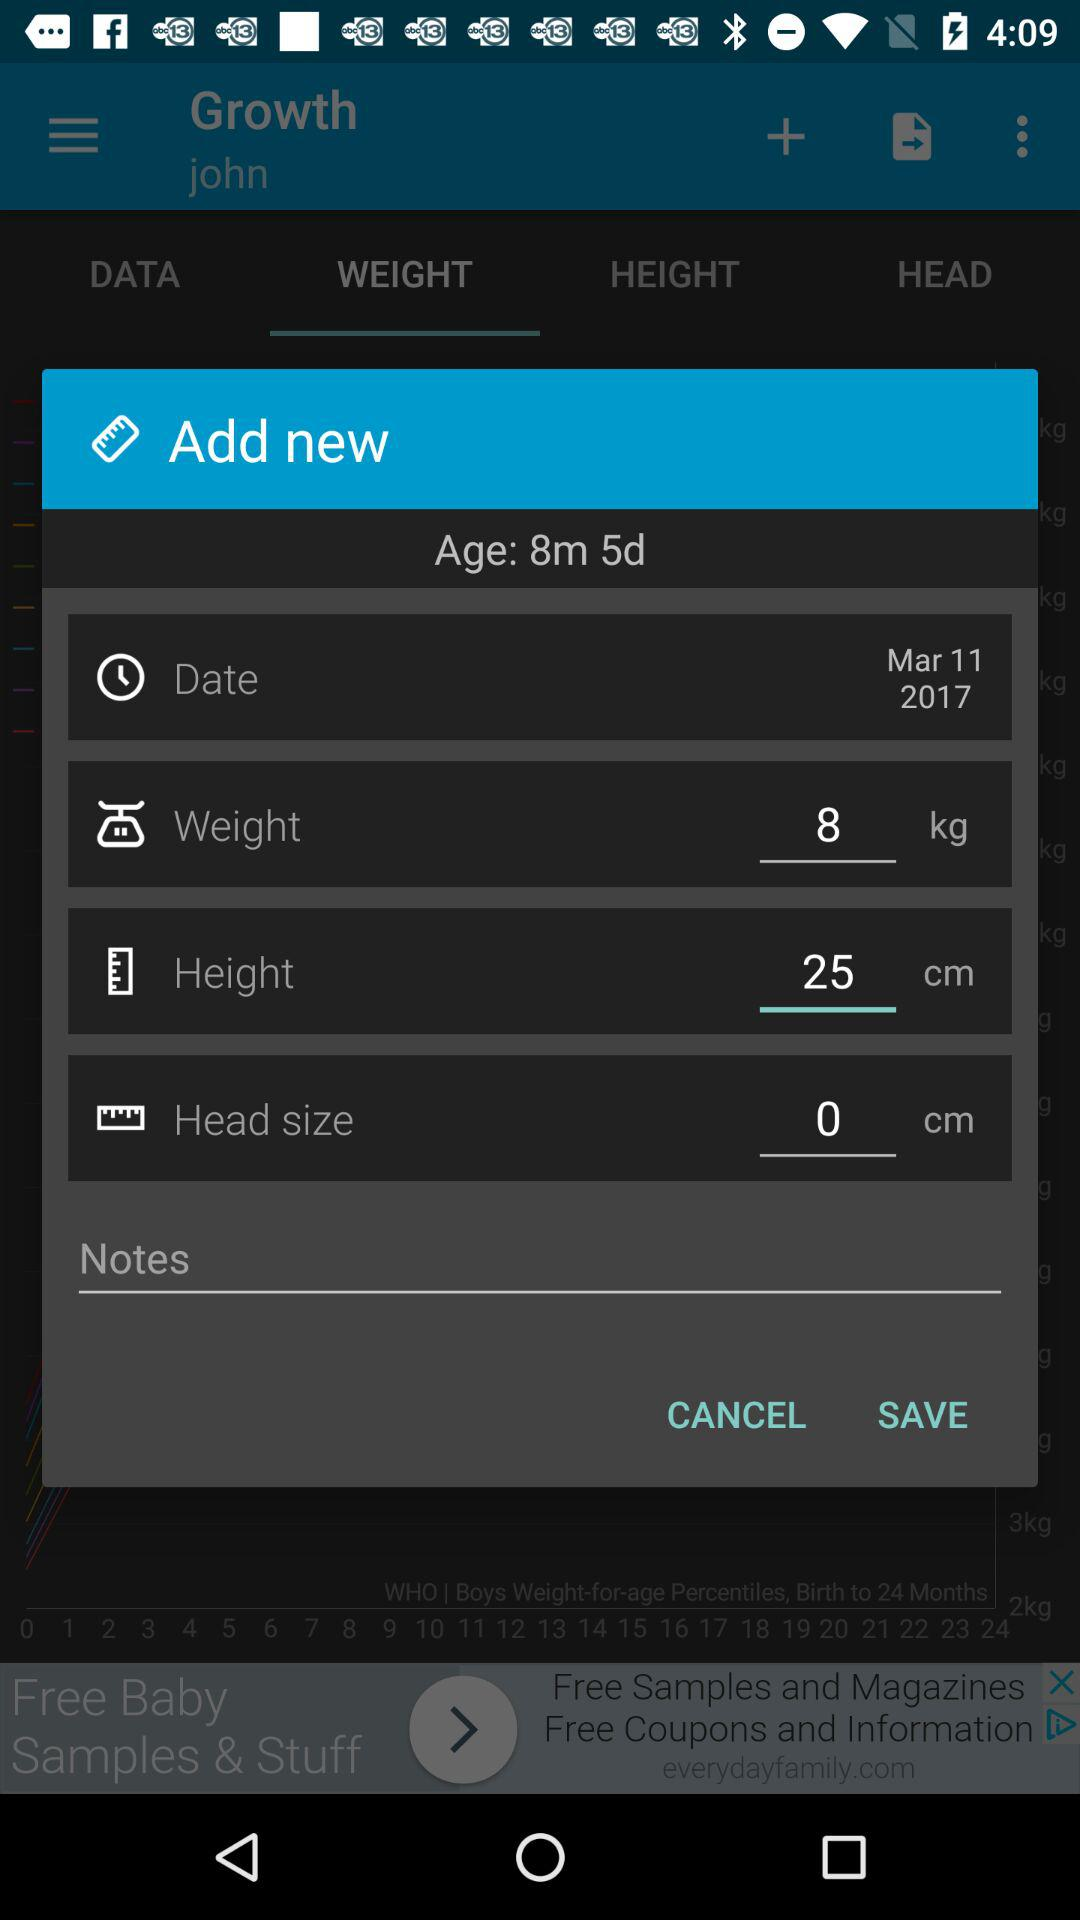Based on the weight entry for 8 kilograms, what could be the usual range for height and head circumference for a baby of this age? For a baby around 8 months old, weighing 8 kilograms, typical height could range from 67 to 76 centimeters and head circumference might vary from 43 to 47 centimeters. However, it is important to remember that normal ranges can vary significantly, and individual growth patterns are often the best indicator of healthy development. 